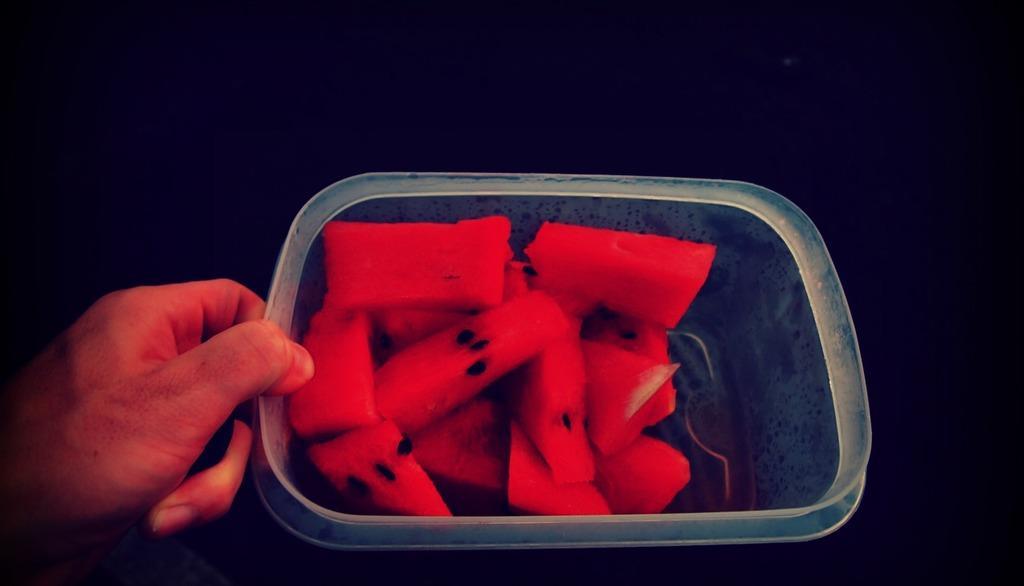How would you summarize this image in a sentence or two? In this image, we can see some food item in a container. We can also see the hand of a person holding the container. 